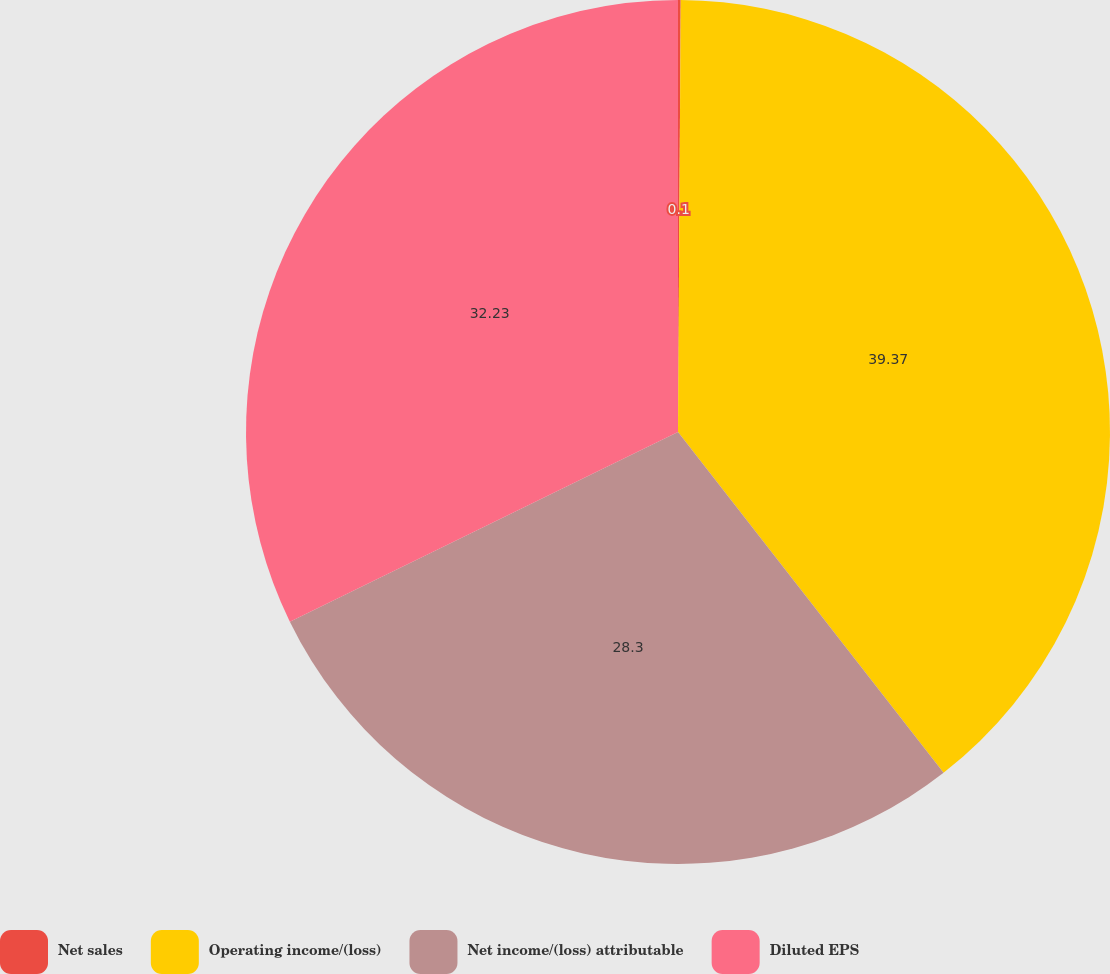Convert chart to OTSL. <chart><loc_0><loc_0><loc_500><loc_500><pie_chart><fcel>Net sales<fcel>Operating income/(loss)<fcel>Net income/(loss) attributable<fcel>Diluted EPS<nl><fcel>0.1%<fcel>39.36%<fcel>28.3%<fcel>32.23%<nl></chart> 